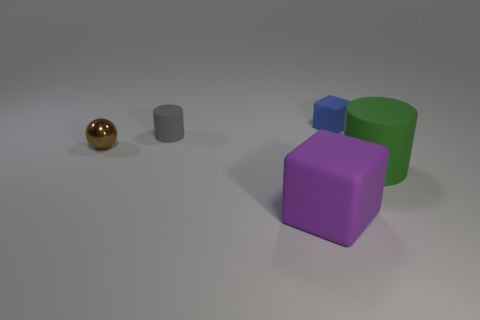Do the ball and the blue block have the same size?
Your answer should be very brief. Yes. What number of cubes are either big purple things or tiny blue things?
Your answer should be very brief. 2. Is the size of the gray object the same as the matte cube behind the shiny sphere?
Keep it short and to the point. Yes. Are there more rubber cylinders on the left side of the large green thing than big brown rubber cylinders?
Your response must be concise. Yes. There is another cube that is the same material as the tiny cube; what is its size?
Offer a very short reply. Large. How many objects are green objects or rubber cylinders on the right side of the blue rubber cube?
Make the answer very short. 1. Is the number of green cylinders greater than the number of yellow shiny cylinders?
Offer a terse response. Yes. Are there any other small cylinders that have the same material as the green cylinder?
Provide a short and direct response. Yes. What shape is the thing that is to the right of the purple thing and in front of the small blue cube?
Give a very brief answer. Cylinder. How many other things are the same shape as the small brown thing?
Your answer should be very brief. 0. 